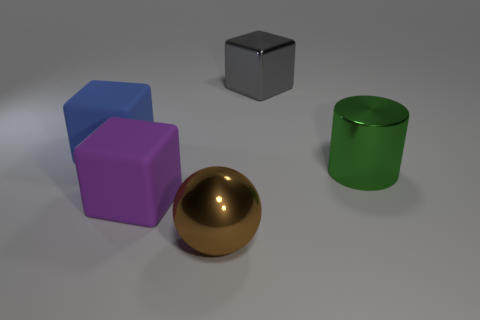Subtract all blue cubes. Subtract all cyan cylinders. How many cubes are left? 2 Add 5 big red metal cylinders. How many objects exist? 10 Subtract all cubes. How many objects are left? 2 Subtract all tiny blue metallic cubes. Subtract all green things. How many objects are left? 4 Add 4 balls. How many balls are left? 5 Add 1 tiny gray rubber objects. How many tiny gray rubber objects exist? 1 Subtract 0 cyan cylinders. How many objects are left? 5 